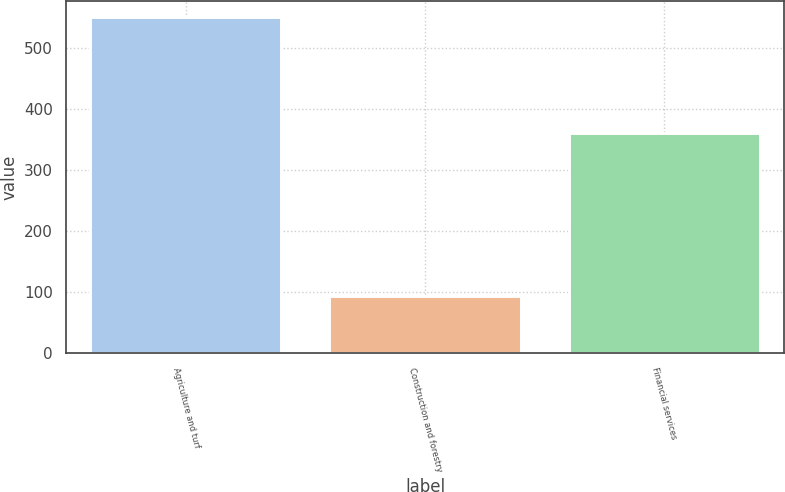Convert chart to OTSL. <chart><loc_0><loc_0><loc_500><loc_500><bar_chart><fcel>Agriculture and turf<fcel>Construction and forestry<fcel>Financial services<nl><fcel>550<fcel>93<fcel>361<nl></chart> 